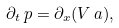<formula> <loc_0><loc_0><loc_500><loc_500>\partial _ { t } \, p = \partial _ { x } ( V \, { a } ) ,</formula> 